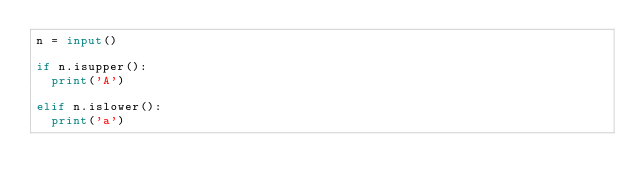Convert code to text. <code><loc_0><loc_0><loc_500><loc_500><_Python_>n = input()

if n.isupper():
  print('A')

elif n.islower():
  print('a')</code> 